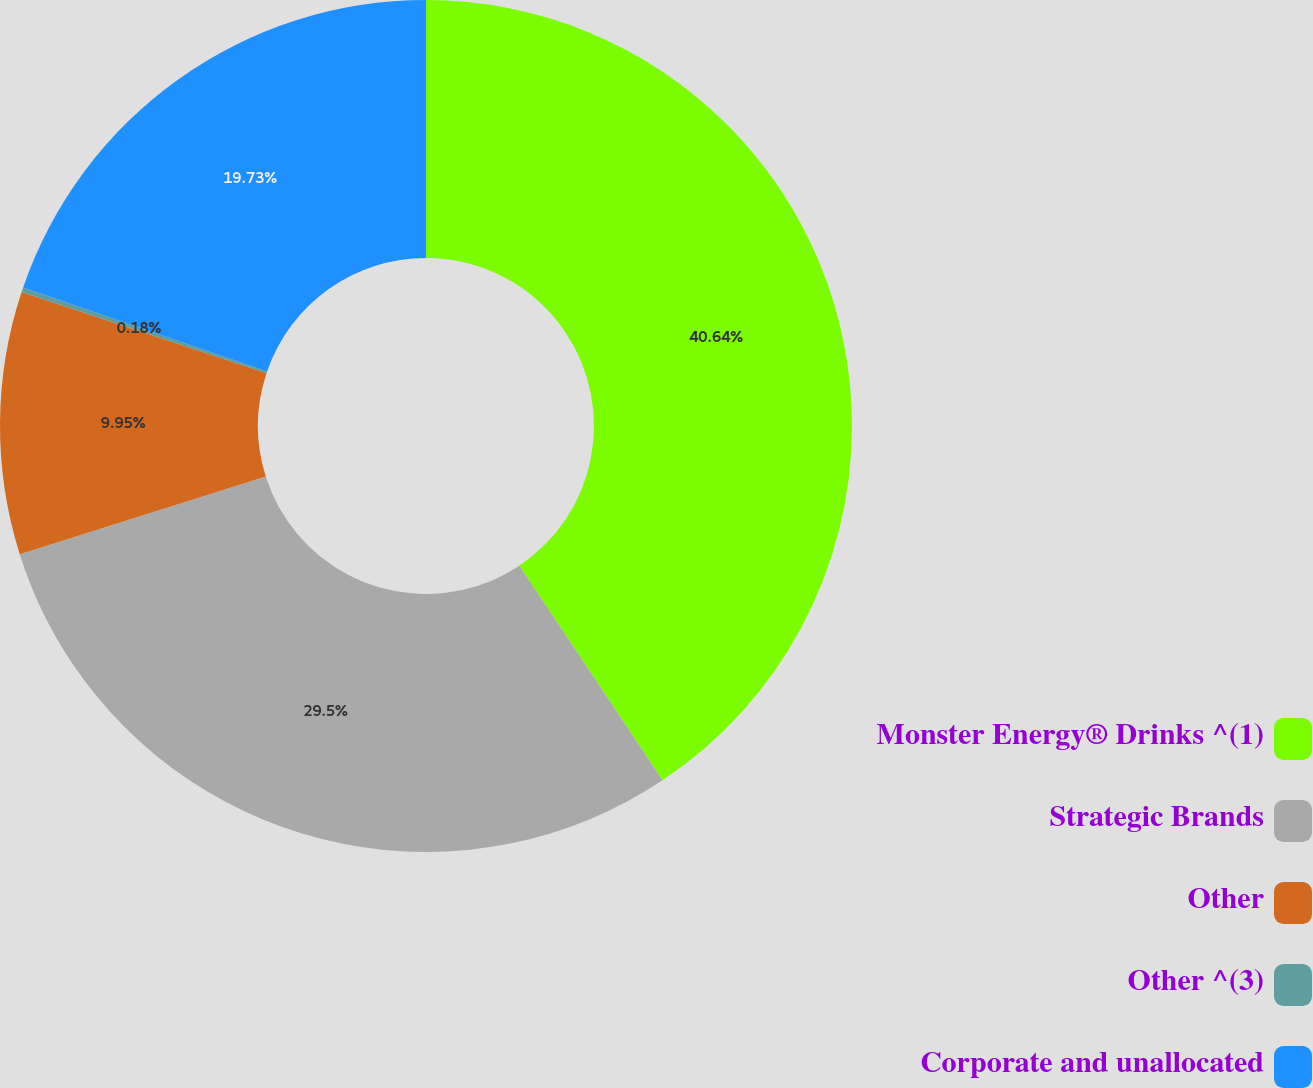Convert chart to OTSL. <chart><loc_0><loc_0><loc_500><loc_500><pie_chart><fcel>Monster Energy® Drinks ^(1)<fcel>Strategic Brands<fcel>Other<fcel>Other ^(3)<fcel>Corporate and unallocated<nl><fcel>40.63%<fcel>29.5%<fcel>9.95%<fcel>0.18%<fcel>19.73%<nl></chart> 